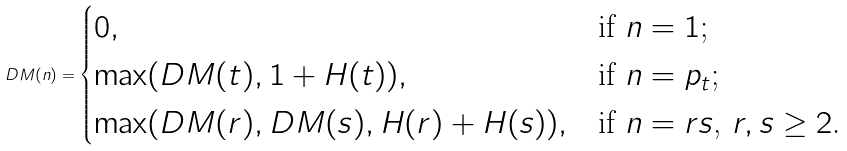Convert formula to latex. <formula><loc_0><loc_0><loc_500><loc_500>D M ( n ) = \begin{cases} 0 , & \text {if $n=1$;} \\ \max ( D M ( t ) , 1 + H ( t ) ) , & \text {if $n=p_{t}$;} \\ \max ( D M ( r ) , D M ( s ) , H ( r ) + H ( s ) ) , & \text {if $n=rs$, $r,s \geq 2$.} \end{cases}</formula> 